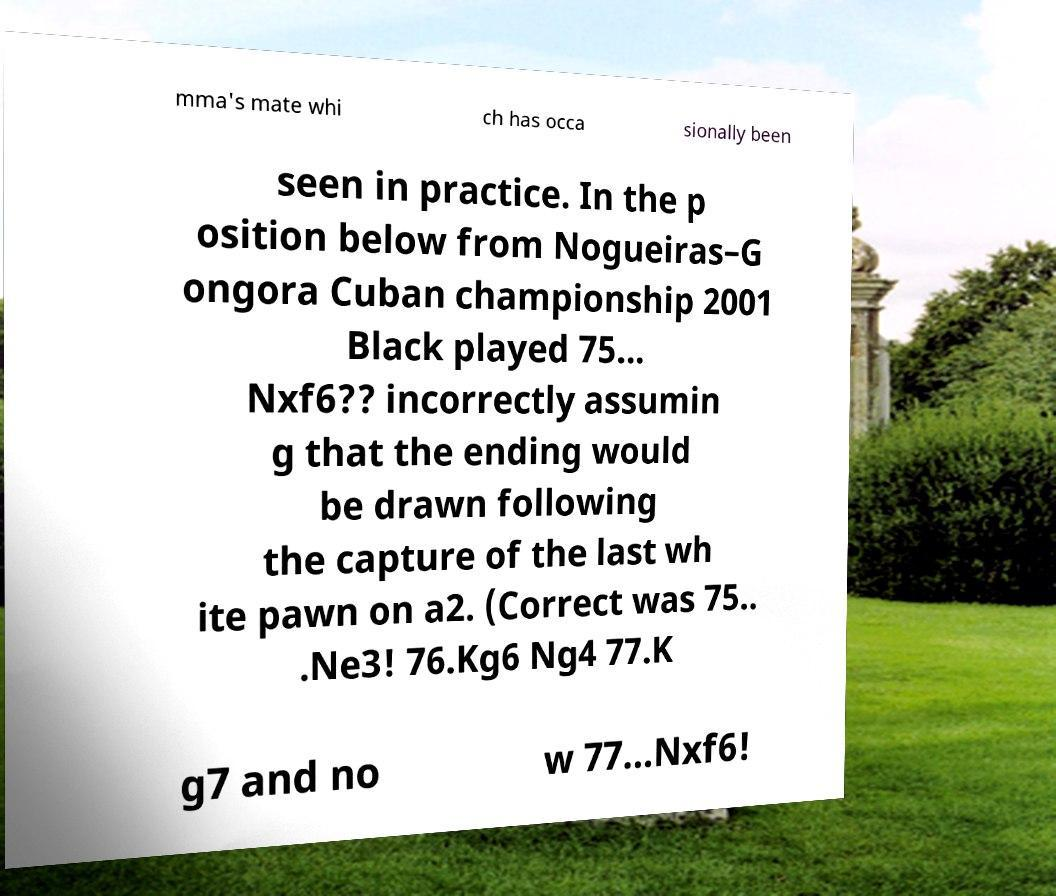Can you accurately transcribe the text from the provided image for me? mma's mate whi ch has occa sionally been seen in practice. In the p osition below from Nogueiras–G ongora Cuban championship 2001 Black played 75... Nxf6?? incorrectly assumin g that the ending would be drawn following the capture of the last wh ite pawn on a2. (Correct was 75.. .Ne3! 76.Kg6 Ng4 77.K g7 and no w 77...Nxf6! 